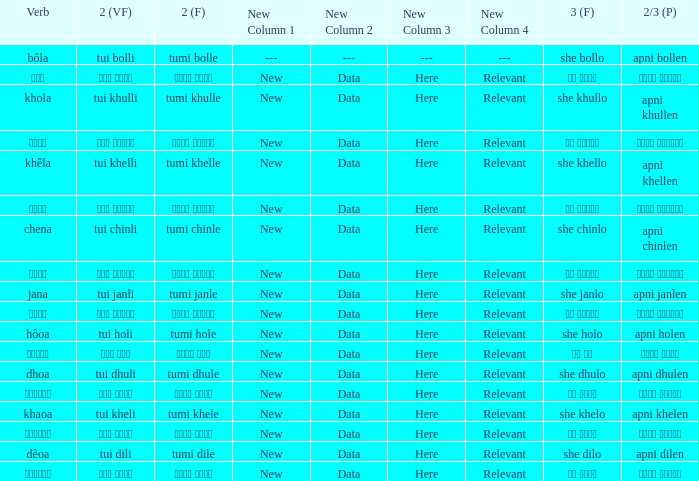What is the verb for Khola? She khullo. 